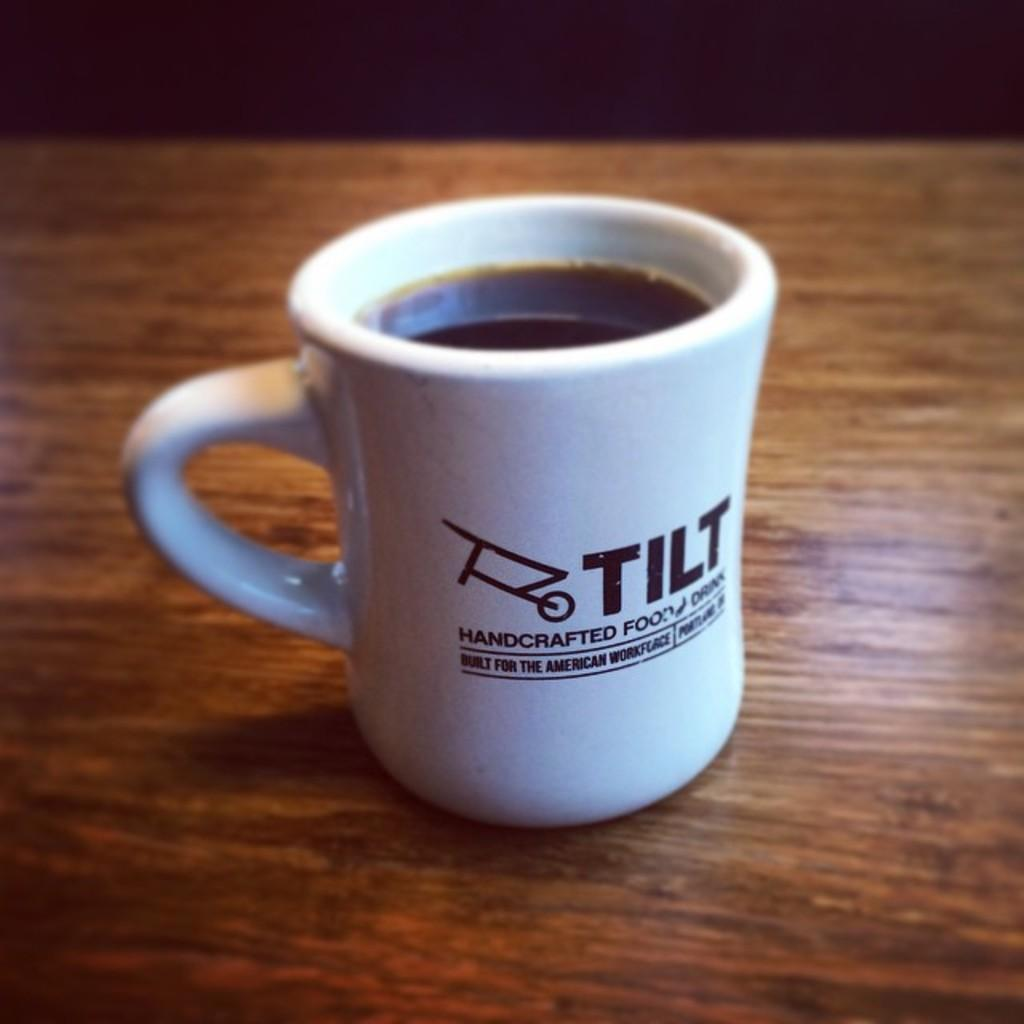What is the main object in the center of the image? There is a table in the center of the image. What is placed on the table? There is a cup on the table. What is inside the cup? There is a drink in the cup. Where is the tub located in the image? There is no tub present in the image. What type of vegetable is being served alongside the drink in the image? There is no vegetable, such as celery, present in the image. 